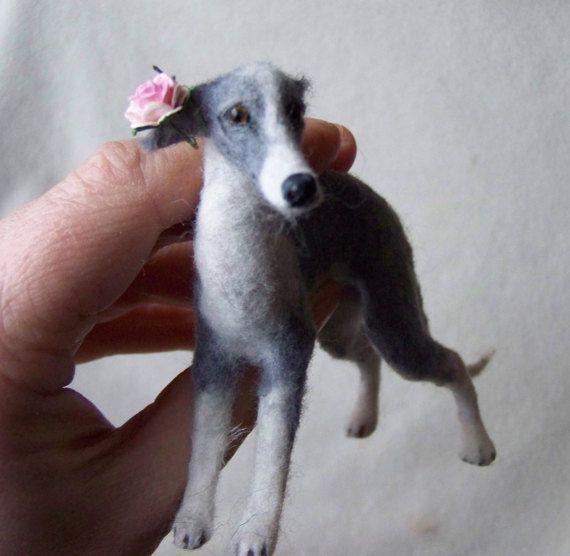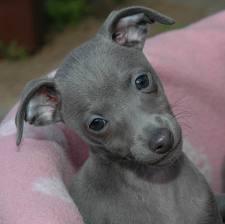The first image is the image on the left, the second image is the image on the right. Considering the images on both sides, is "At least one dog is wearing a collar." valid? Answer yes or no. No. The first image is the image on the left, the second image is the image on the right. Given the left and right images, does the statement "An image shows a hound wearing a collar and sitting upright." hold true? Answer yes or no. No. 